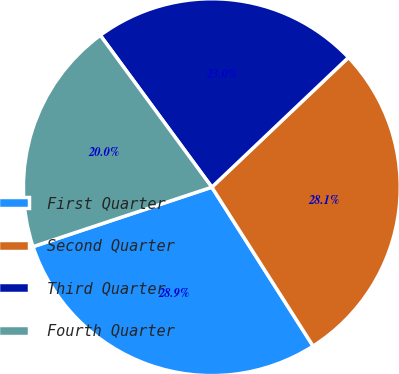<chart> <loc_0><loc_0><loc_500><loc_500><pie_chart><fcel>First Quarter<fcel>Second Quarter<fcel>Third Quarter<fcel>Fourth Quarter<nl><fcel>28.92%<fcel>28.06%<fcel>22.99%<fcel>20.03%<nl></chart> 